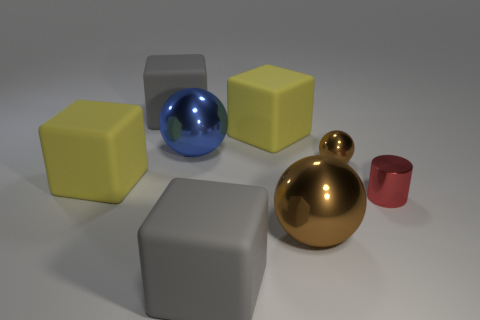Are there any other things that have the same color as the tiny metal sphere?
Your answer should be compact. Yes. The small cylinder has what color?
Keep it short and to the point. Red. Are there any large brown balls?
Your answer should be very brief. Yes. Are there any red objects behind the large brown ball?
Your response must be concise. Yes. What is the material of the other brown object that is the same shape as the big brown thing?
Your answer should be compact. Metal. Are there any other things that have the same material as the red thing?
Make the answer very short. Yes. What number of other things are the same shape as the large blue metallic object?
Give a very brief answer. 2. There is a large metallic thing behind the brown metallic sphere that is behind the large brown sphere; how many large balls are on the left side of it?
Your answer should be compact. 0. How many large blue metallic objects are the same shape as the small red object?
Give a very brief answer. 0. There is a tiny thing that is behind the shiny cylinder; does it have the same color as the cylinder?
Ensure brevity in your answer.  No. 